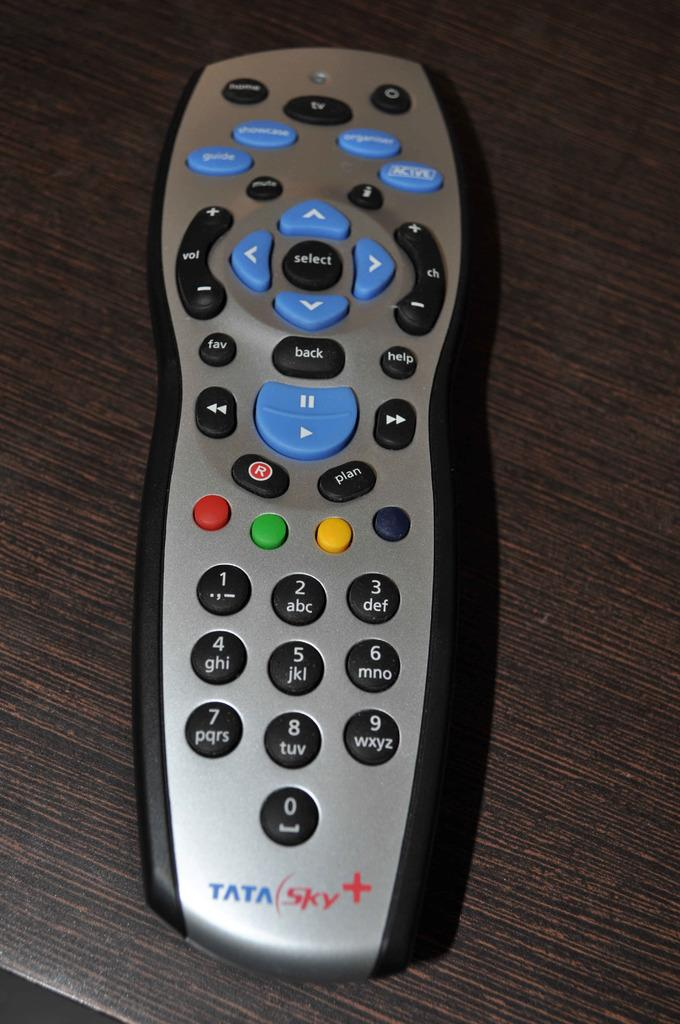<image>
Share a concise interpretation of the image provided. A Tata sky + remote that has a select button in the middle of 4 arrow buttons,  lays on a wooden surface 